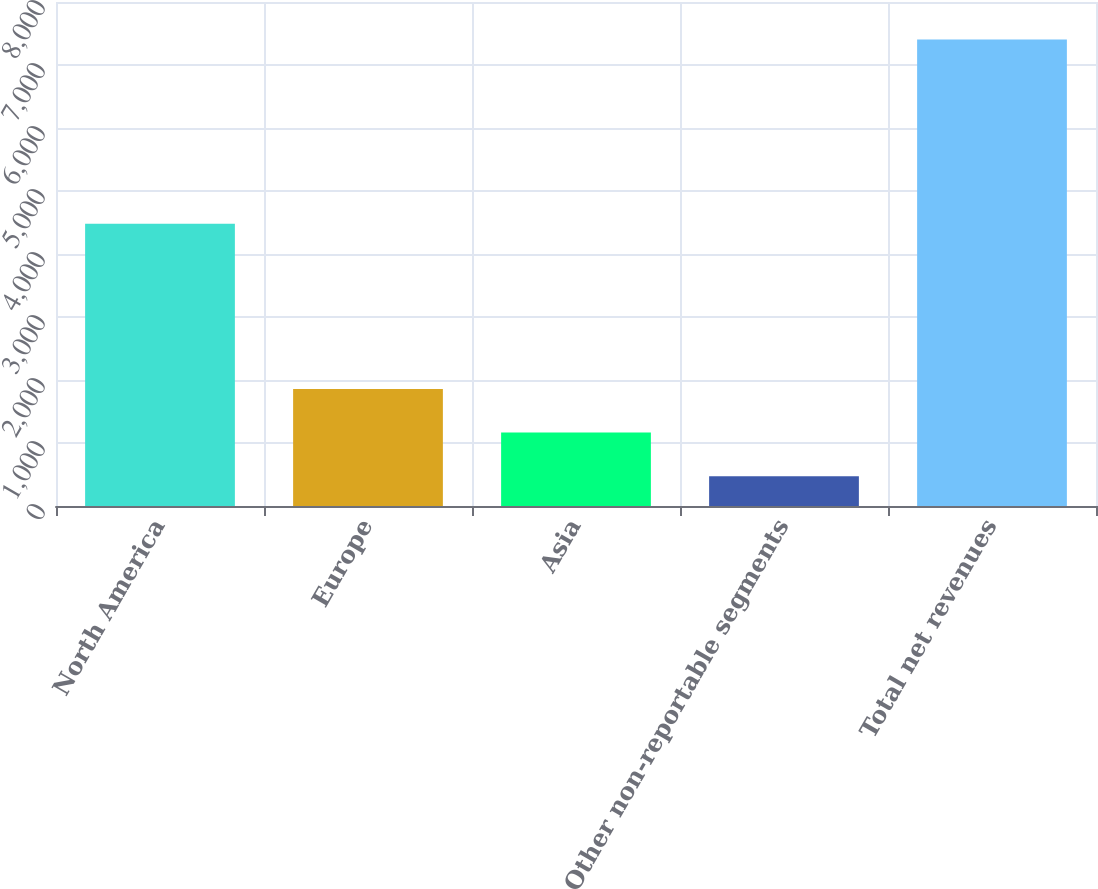<chart> <loc_0><loc_0><loc_500><loc_500><bar_chart><fcel>North America<fcel>Europe<fcel>Asia<fcel>Other non-reportable segments<fcel>Total net revenues<nl><fcel>4479.6<fcel>1858.24<fcel>1164.87<fcel>471.5<fcel>7405.2<nl></chart> 